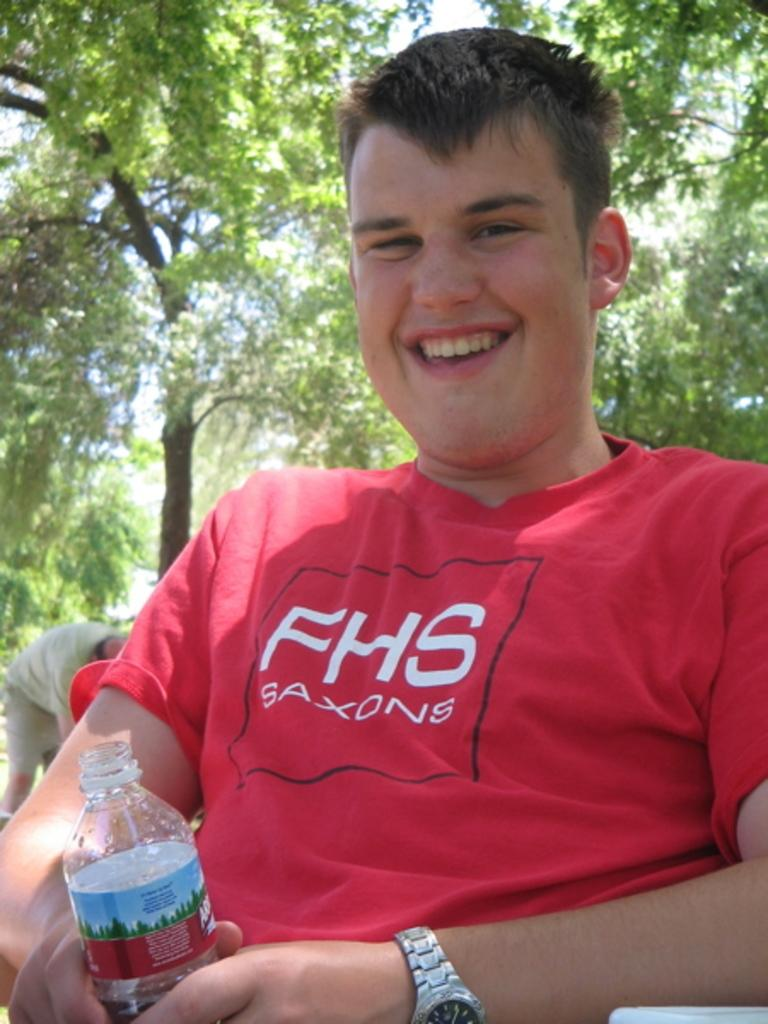Who is present in the image? There is a man in the image. What is the man doing in the image? The man is seated on a chair. What is the man holding in his hand? The man is holding a bottle in his hand. What can be seen in the background of the image? There are trees visible in the image. What type of brush is the man using to smash the bears in the image? There are no brushes, smashing, or bears present in the image. 